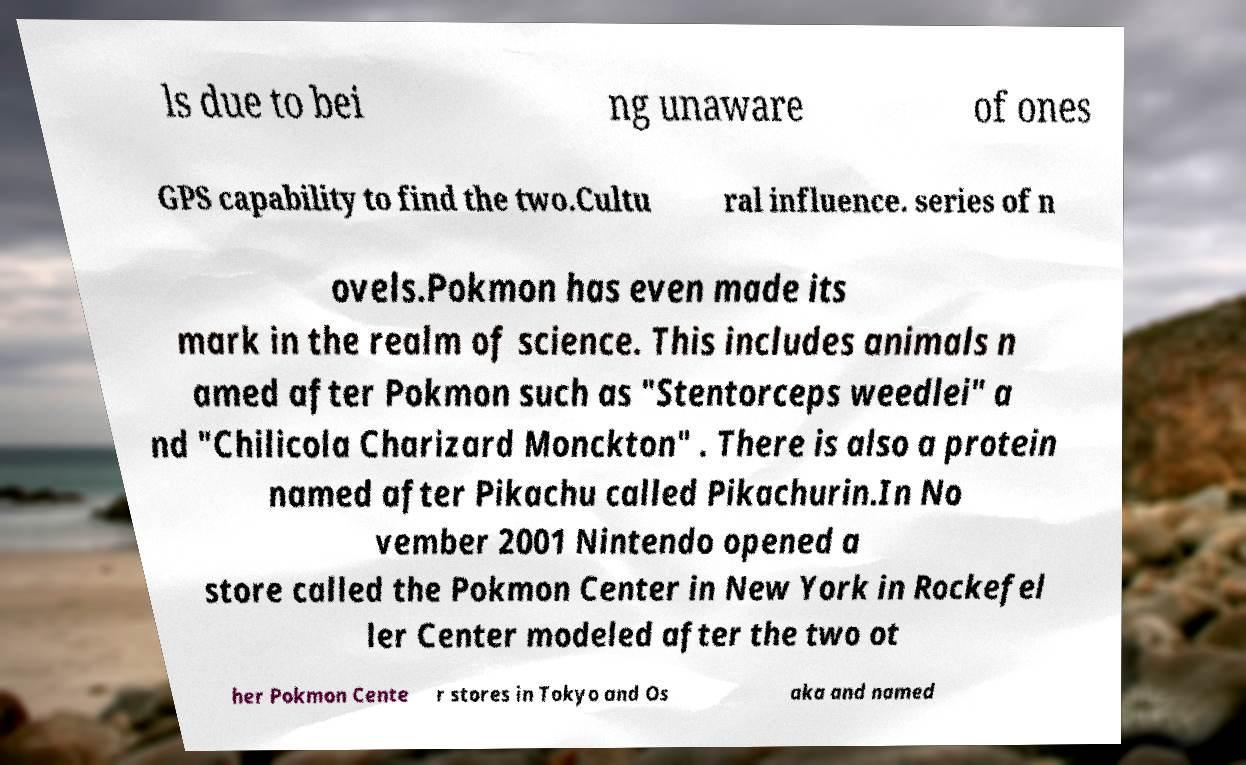I need the written content from this picture converted into text. Can you do that? ls due to bei ng unaware of ones GPS capability to find the two.Cultu ral influence. series of n ovels.Pokmon has even made its mark in the realm of science. This includes animals n amed after Pokmon such as "Stentorceps weedlei" a nd "Chilicola Charizard Monckton" . There is also a protein named after Pikachu called Pikachurin.In No vember 2001 Nintendo opened a store called the Pokmon Center in New York in Rockefel ler Center modeled after the two ot her Pokmon Cente r stores in Tokyo and Os aka and named 